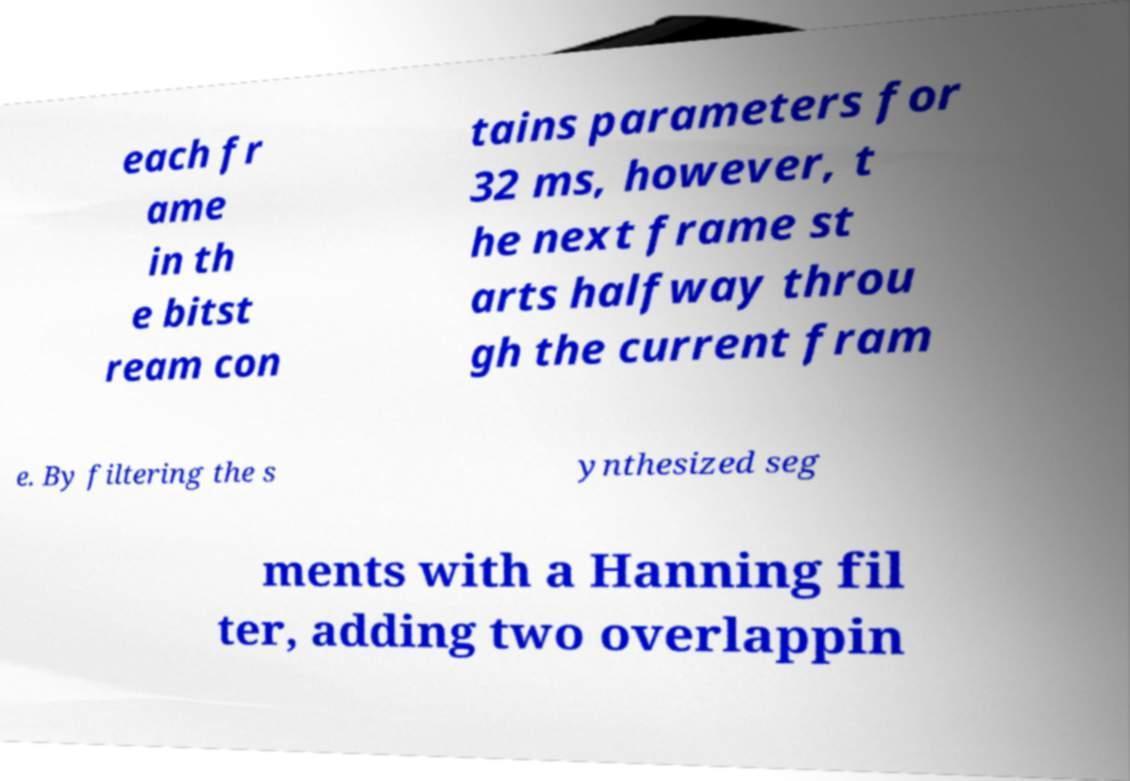Can you accurately transcribe the text from the provided image for me? each fr ame in th e bitst ream con tains parameters for 32 ms, however, t he next frame st arts halfway throu gh the current fram e. By filtering the s ynthesized seg ments with a Hanning fil ter, adding two overlappin 